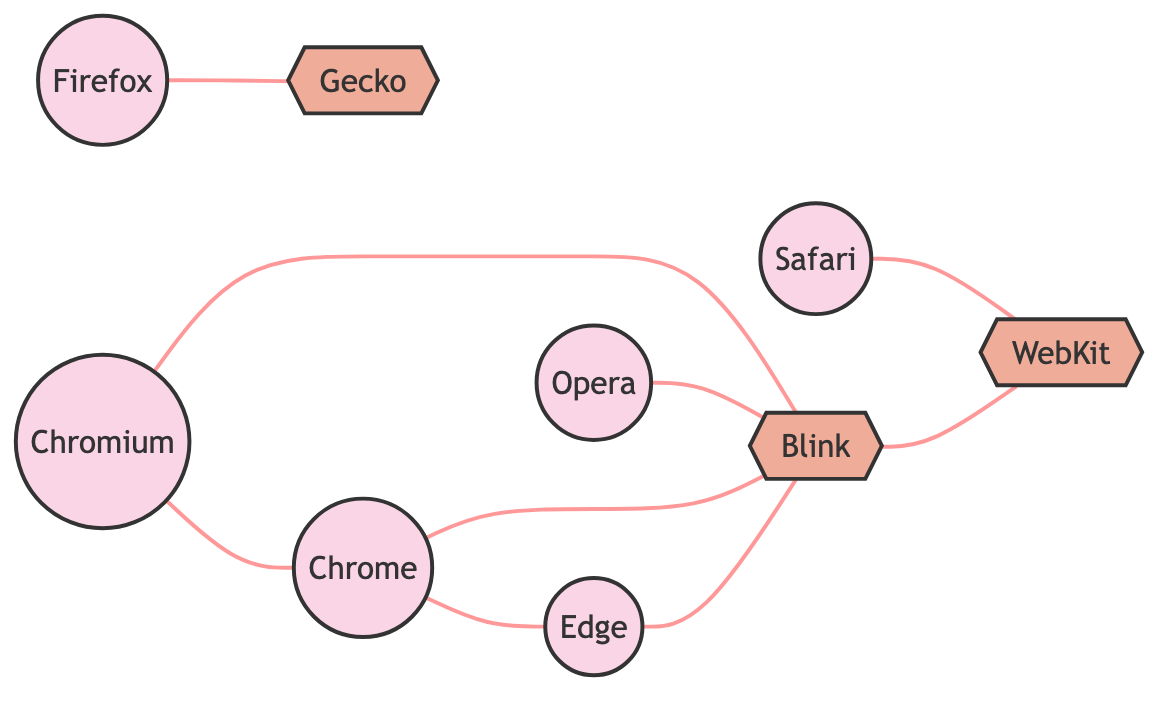What is the number of web browsers represented in the graph? The graph includes nodes labeled as web browsers: Google Chrome, Mozilla Firefox, Apple Safari, Microsoft Edge, and Opera. Counting these nodes gives us a total of 5 web browsers.
Answer: 5 Which web engine is associated with Mozilla Firefox? According to the edges in the graph, the connection between Mozilla Firefox and its corresponding web engine is indicated by the edge that leads to Gecko.
Answer: Gecko How many edges connect to the web engine Blink? The edges connected to Blink include connections from Google Chrome, Microsoft Edge, Opera, and Chromium. Counting these connections gives us a total of 4 edges.
Answer: 4 Which web browser shares an edge with Chromium? The graph shows that the edge from Chromium leads to both Google Chrome and Blink, indicating that Google Chrome is also connected.
Answer: Google Chrome What is the relationship between Safari and its associated web engine? The edge connecting Apple Safari to its corresponding web engine is indicated by the single edge leading to WebKit, showing a direct relationship.
Answer: WebKit Are Google Chrome and Microsoft Edge connected to the same web engine? Both Google Chrome and Microsoft Edge have edges that lead to Blink, indicating that they share this web engine. Therefore, they are connected through Blink.
Answer: Yes Which web browser has the most connections to web engines? Upon examining the edges, Blink is involved with multiple browsers: Google Chrome, Microsoft Edge, Opera, and Chromium, indicating that it serves as the most connected web engine.
Answer: Blink How many unique web engines are represented in the graph? Counting the distinct web engines, we find three: Blink, WebKit, and Gecko. This totals to three unique web engines in the graph.
Answer: 3 What is the direct connection of the browser Opera in the graph? According to the edges, Opera connects directly to the web engine Blink, illustrating its relationship.
Answer: Blink 